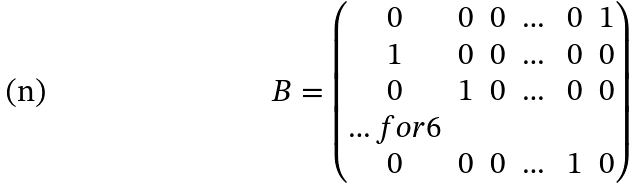Convert formula to latex. <formula><loc_0><loc_0><loc_500><loc_500>B = \begin{pmatrix} 0 & 0 & 0 & \dots & 0 & 1 \\ 1 & 0 & 0 & \dots & 0 & 0 \\ 0 & 1 & 0 & \dots & 0 & 0 \\ \hdots f o r { 6 } \\ 0 & 0 & 0 & \dots & 1 & 0 \end{pmatrix}</formula> 